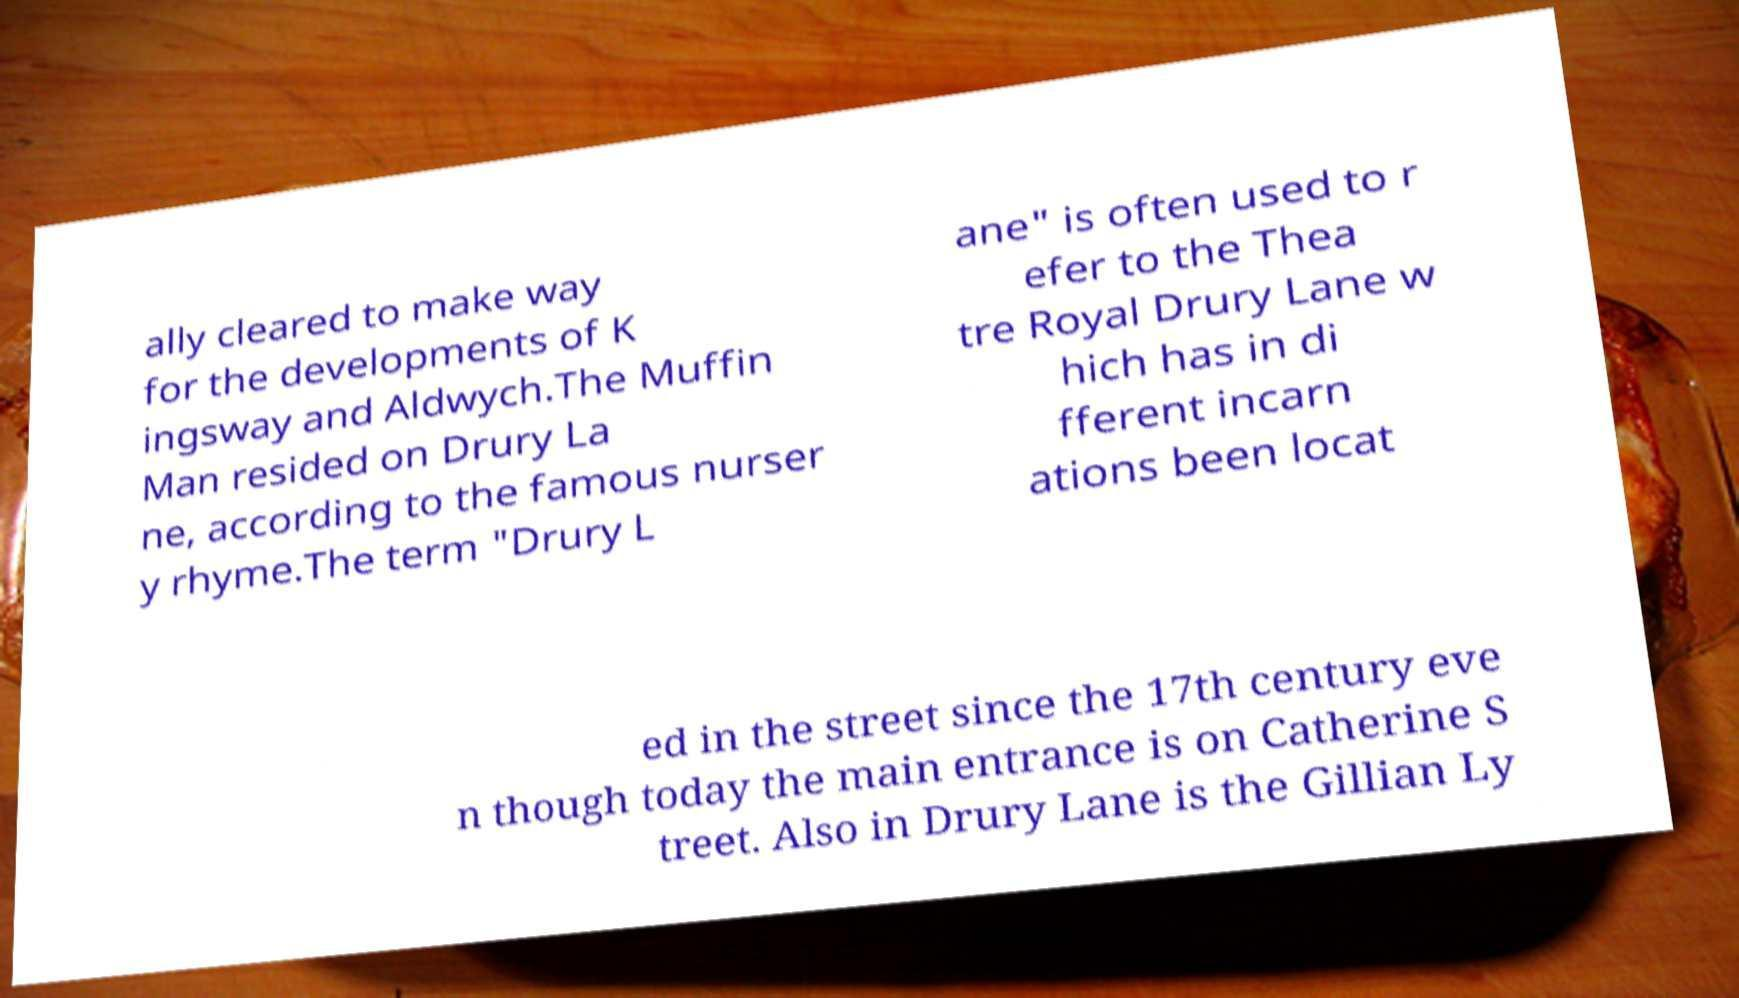What messages or text are displayed in this image? I need them in a readable, typed format. ally cleared to make way for the developments of K ingsway and Aldwych.The Muffin Man resided on Drury La ne, according to the famous nurser y rhyme.The term "Drury L ane" is often used to r efer to the Thea tre Royal Drury Lane w hich has in di fferent incarn ations been locat ed in the street since the 17th century eve n though today the main entrance is on Catherine S treet. Also in Drury Lane is the Gillian Ly 